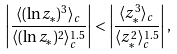Convert formula to latex. <formula><loc_0><loc_0><loc_500><loc_500>\left | \frac { \langle ( \ln z _ { \ast } ) ^ { 3 } \rangle _ { c } } { \langle ( \ln z _ { \ast } ) ^ { 2 } \rangle _ { c } ^ { 1 . 5 } } \right | < \left | \frac { \langle z _ { \ast } ^ { 3 } \rangle _ { c } } { \langle z _ { \ast } ^ { 2 } \rangle _ { c } ^ { 1 . 5 } } \right | ,</formula> 